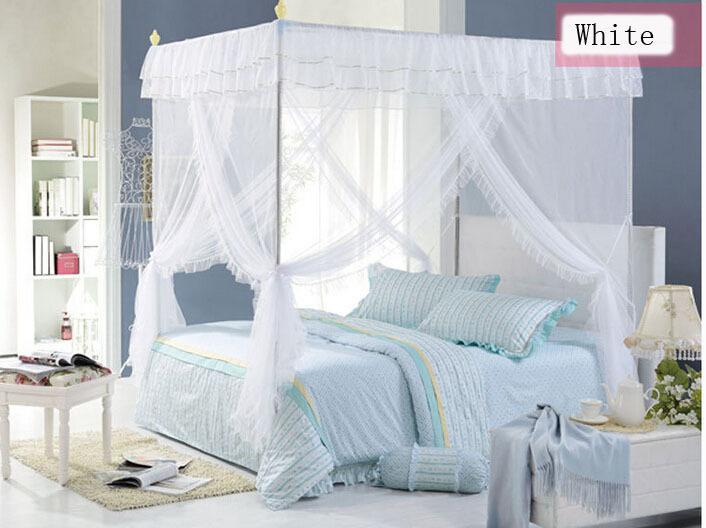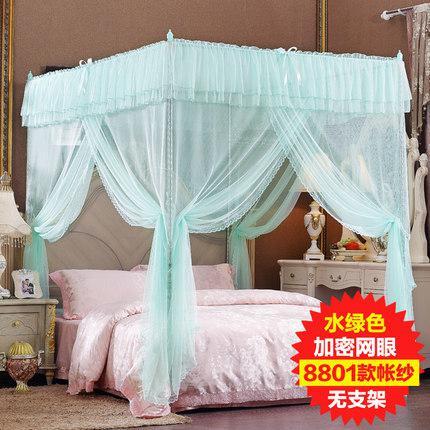The first image is the image on the left, the second image is the image on the right. Given the left and right images, does the statement "Green bed drapes are tied on to bed poles." hold true? Answer yes or no. Yes. The first image is the image on the left, the second image is the image on the right. Evaluate the accuracy of this statement regarding the images: "A bed has an aqua colored canopy that is gathered at the four posts.". Is it true? Answer yes or no. Yes. 